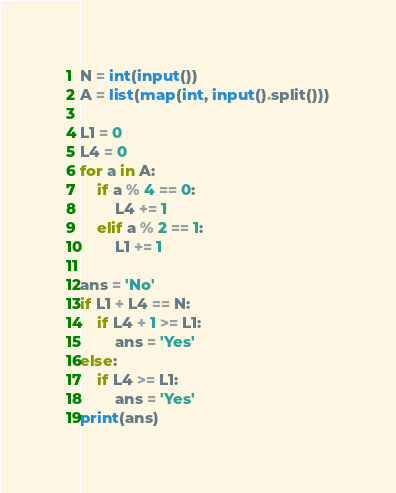Convert code to text. <code><loc_0><loc_0><loc_500><loc_500><_Python_>N = int(input())
A = list(map(int, input().split()))

L1 = 0
L4 = 0
for a in A:
    if a % 4 == 0:
        L4 += 1
    elif a % 2 == 1:
        L1 += 1

ans = 'No'
if L1 + L4 == N:
    if L4 + 1 >= L1:
        ans = 'Yes'
else:
    if L4 >= L1:
        ans = 'Yes'
print(ans)
</code> 